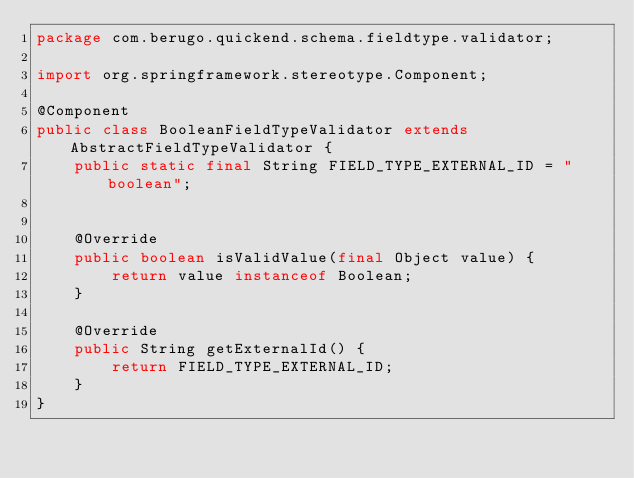Convert code to text. <code><loc_0><loc_0><loc_500><loc_500><_Java_>package com.berugo.quickend.schema.fieldtype.validator;

import org.springframework.stereotype.Component;

@Component
public class BooleanFieldTypeValidator extends AbstractFieldTypeValidator {
    public static final String FIELD_TYPE_EXTERNAL_ID = "boolean";


    @Override
    public boolean isValidValue(final Object value) {
        return value instanceof Boolean;
    }

    @Override
    public String getExternalId() {
        return FIELD_TYPE_EXTERNAL_ID;
    }
}
</code> 